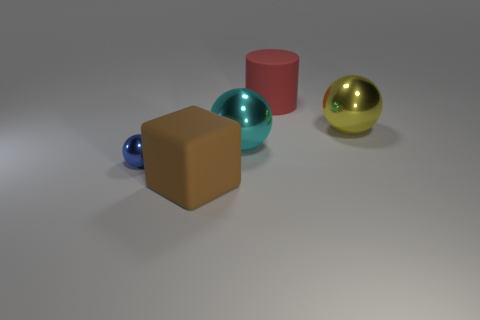Add 2 large metal cubes. How many objects exist? 7 Subtract all big balls. How many balls are left? 1 Subtract 3 spheres. How many spheres are left? 0 Subtract all brown balls. Subtract all yellow cylinders. How many balls are left? 3 Subtract all brown cylinders. How many green spheres are left? 0 Subtract all blue metal balls. Subtract all brown cubes. How many objects are left? 3 Add 1 small blue metal balls. How many small blue metal balls are left? 2 Add 4 big gray metal spheres. How many big gray metal spheres exist? 4 Subtract all blue balls. How many balls are left? 2 Subtract 0 brown cylinders. How many objects are left? 5 